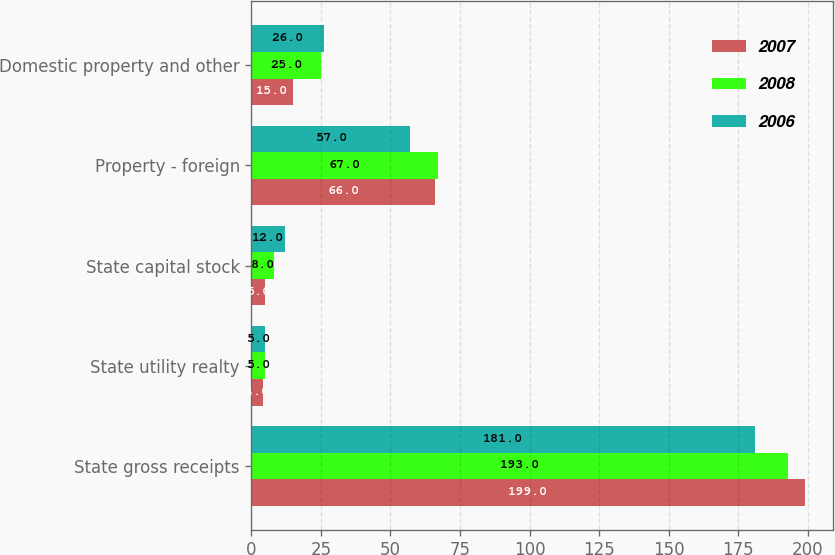Convert chart to OTSL. <chart><loc_0><loc_0><loc_500><loc_500><stacked_bar_chart><ecel><fcel>State gross receipts<fcel>State utility realty<fcel>State capital stock<fcel>Property - foreign<fcel>Domestic property and other<nl><fcel>2007<fcel>199<fcel>4<fcel>5<fcel>66<fcel>15<nl><fcel>2008<fcel>193<fcel>5<fcel>8<fcel>67<fcel>25<nl><fcel>2006<fcel>181<fcel>5<fcel>12<fcel>57<fcel>26<nl></chart> 